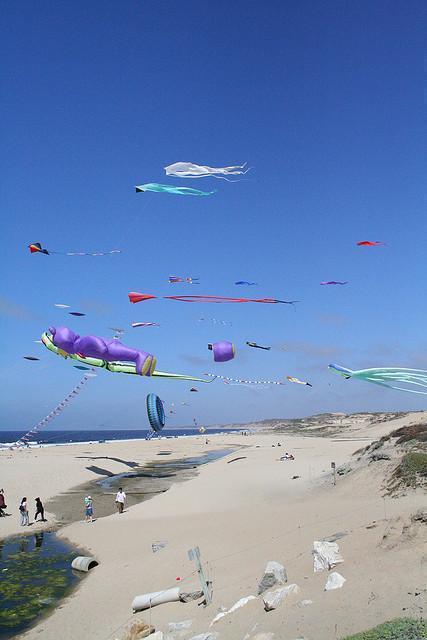What direction is the wind blowing?
Make your selection and explain in format: 'Answer: answer
Rationale: rationale.'
Options: Left, down, right, up. Answer: right.
Rationale: All of the kites are headed to the right. 